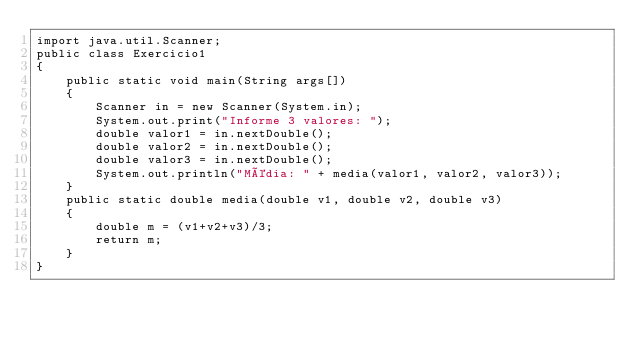<code> <loc_0><loc_0><loc_500><loc_500><_Java_>import java.util.Scanner;
public class Exercicio1
{
    public static void main(String args[])
    {
        Scanner in = new Scanner(System.in);
        System.out.print("Informe 3 valores: ");
        double valor1 = in.nextDouble();
        double valor2 = in.nextDouble();
        double valor3 = in.nextDouble();
        System.out.println("Média: " + media(valor1, valor2, valor3));
    }
    public static double media(double v1, double v2, double v3)
    {
        double m = (v1+v2+v3)/3;
        return m;
    }
}</code> 